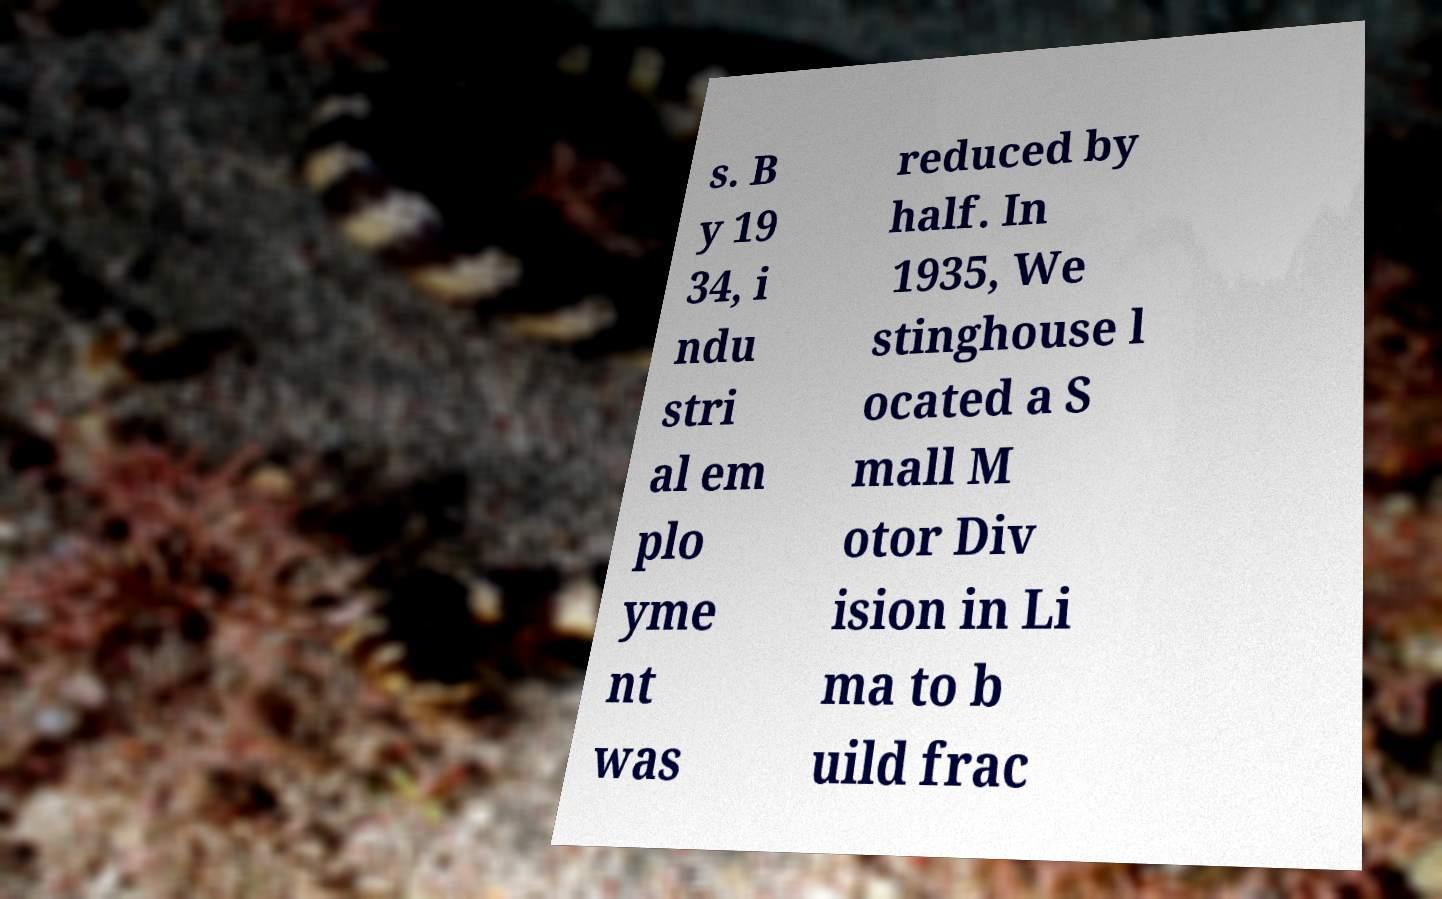For documentation purposes, I need the text within this image transcribed. Could you provide that? s. B y 19 34, i ndu stri al em plo yme nt was reduced by half. In 1935, We stinghouse l ocated a S mall M otor Div ision in Li ma to b uild frac 